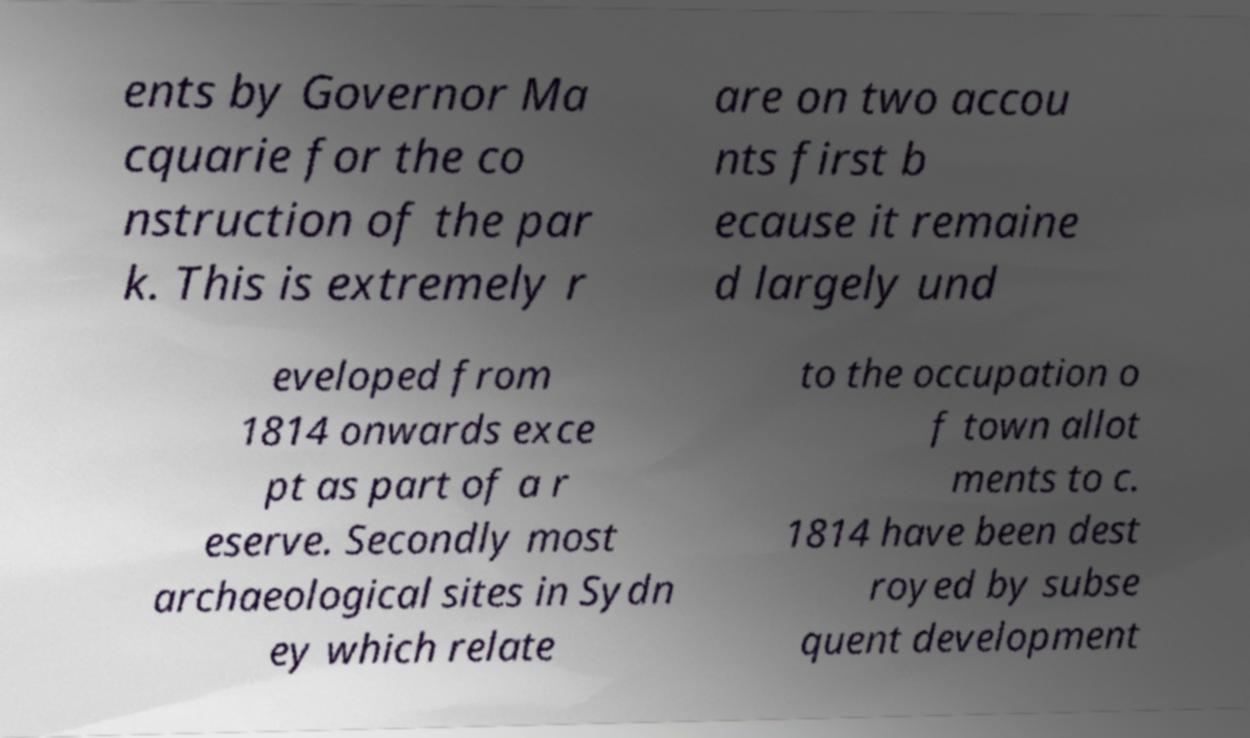Please read and relay the text visible in this image. What does it say? ents by Governor Ma cquarie for the co nstruction of the par k. This is extremely r are on two accou nts first b ecause it remaine d largely und eveloped from 1814 onwards exce pt as part of a r eserve. Secondly most archaeological sites in Sydn ey which relate to the occupation o f town allot ments to c. 1814 have been dest royed by subse quent development 